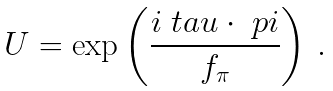Convert formula to latex. <formula><loc_0><loc_0><loc_500><loc_500>U = \exp \left ( \frac { i \boldmath \ t a u \cdot \boldmath \ p i } { f _ { \pi } } \right ) \, .</formula> 